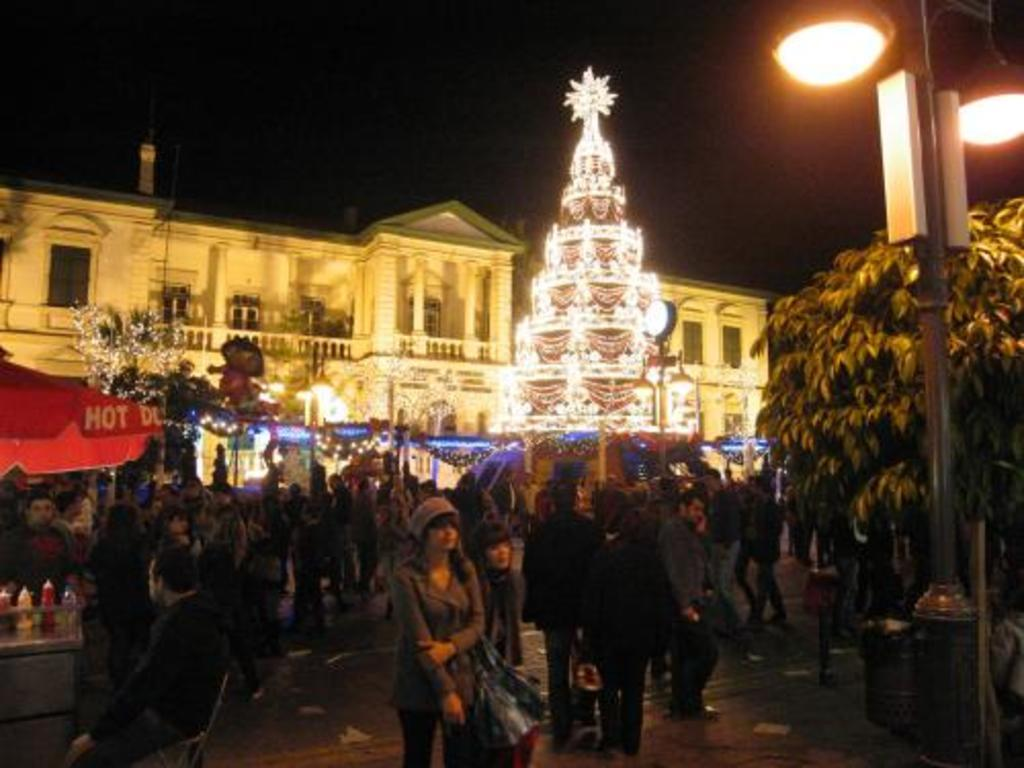What type of structure is present in the image? There is a building in the image. What can be seen illuminated in the image? There are lights visible in the image. What type of natural elements are present in the image? There are plants in the image. Are there any people present in the image? Yes, there are people in the image. What type of items can be seen as decoration in the image? There are decorative objects in the image. What type of establishment can be seen in the image? There is a food stall in the image. What other objects can be seen in the image? There are other objects in the image. Can you see a toy snake in the image? There is no toy snake present in the image. What type of lift is visible in the image? There is no lift present in the image. 